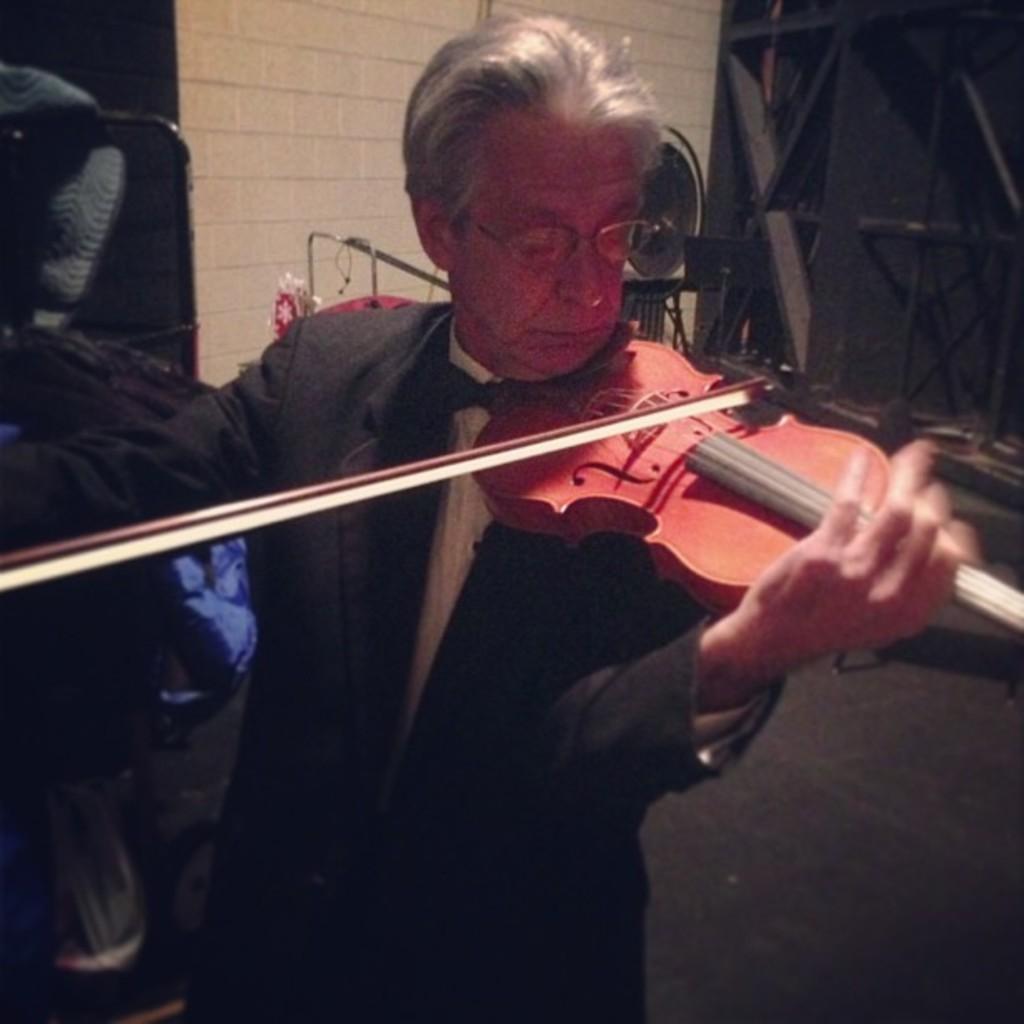Please provide a concise description of this image. This old person wore suit and playing violin, which is in red color. 